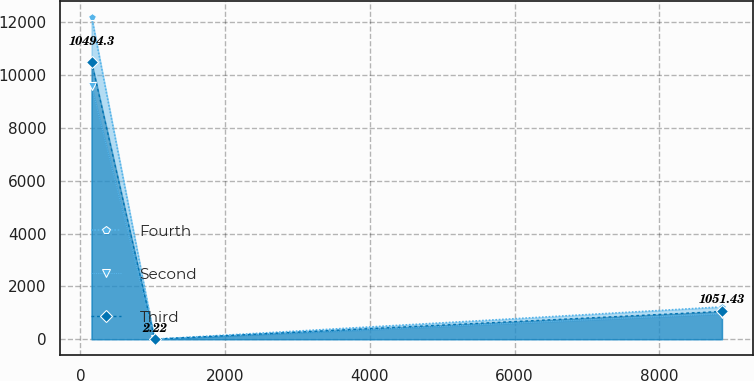<chart> <loc_0><loc_0><loc_500><loc_500><line_chart><ecel><fcel>Fourth<fcel>Second<fcel>Third<nl><fcel>154.09<fcel>12205<fcel>9585.52<fcel>10494.3<nl><fcel>1025.09<fcel>1.51<fcel>1.64<fcel>2.22<nl><fcel>8864.04<fcel>1221.86<fcel>960.03<fcel>1051.43<nl></chart> 